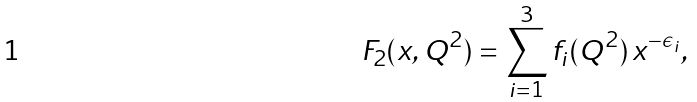<formula> <loc_0><loc_0><loc_500><loc_500>F _ { 2 } ( x , Q ^ { 2 } ) = \sum _ { i = 1 } ^ { 3 } f _ { i } ( Q ^ { 2 } ) \, x ^ { - \epsilon _ { i } } ,</formula> 